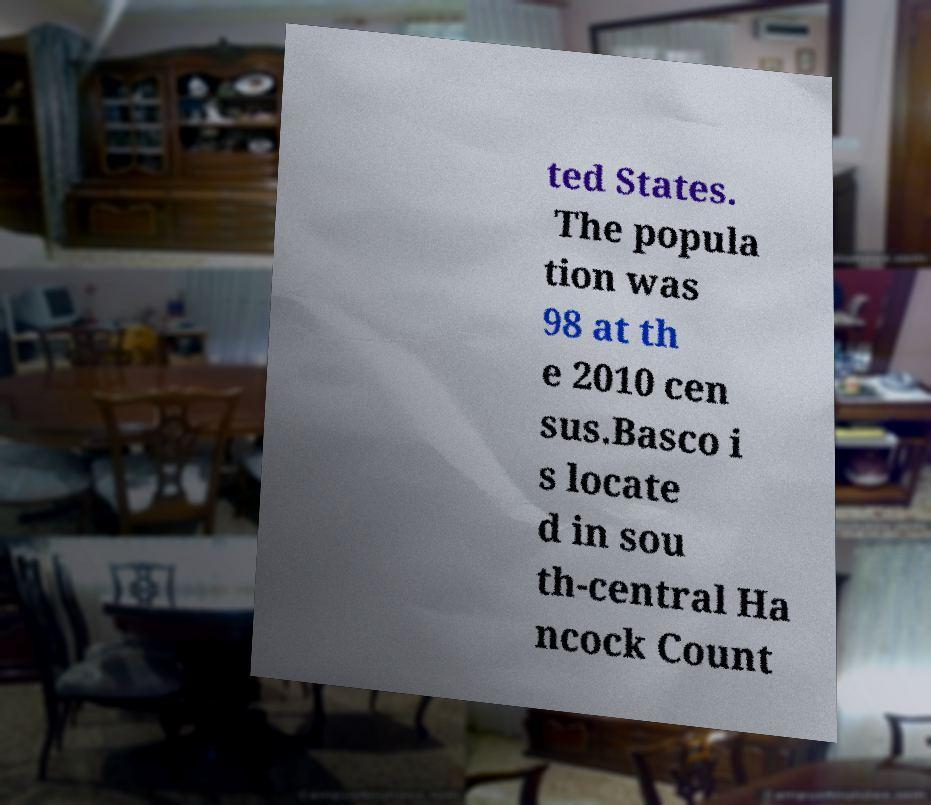What messages or text are displayed in this image? I need them in a readable, typed format. ted States. The popula tion was 98 at th e 2010 cen sus.Basco i s locate d in sou th-central Ha ncock Count 